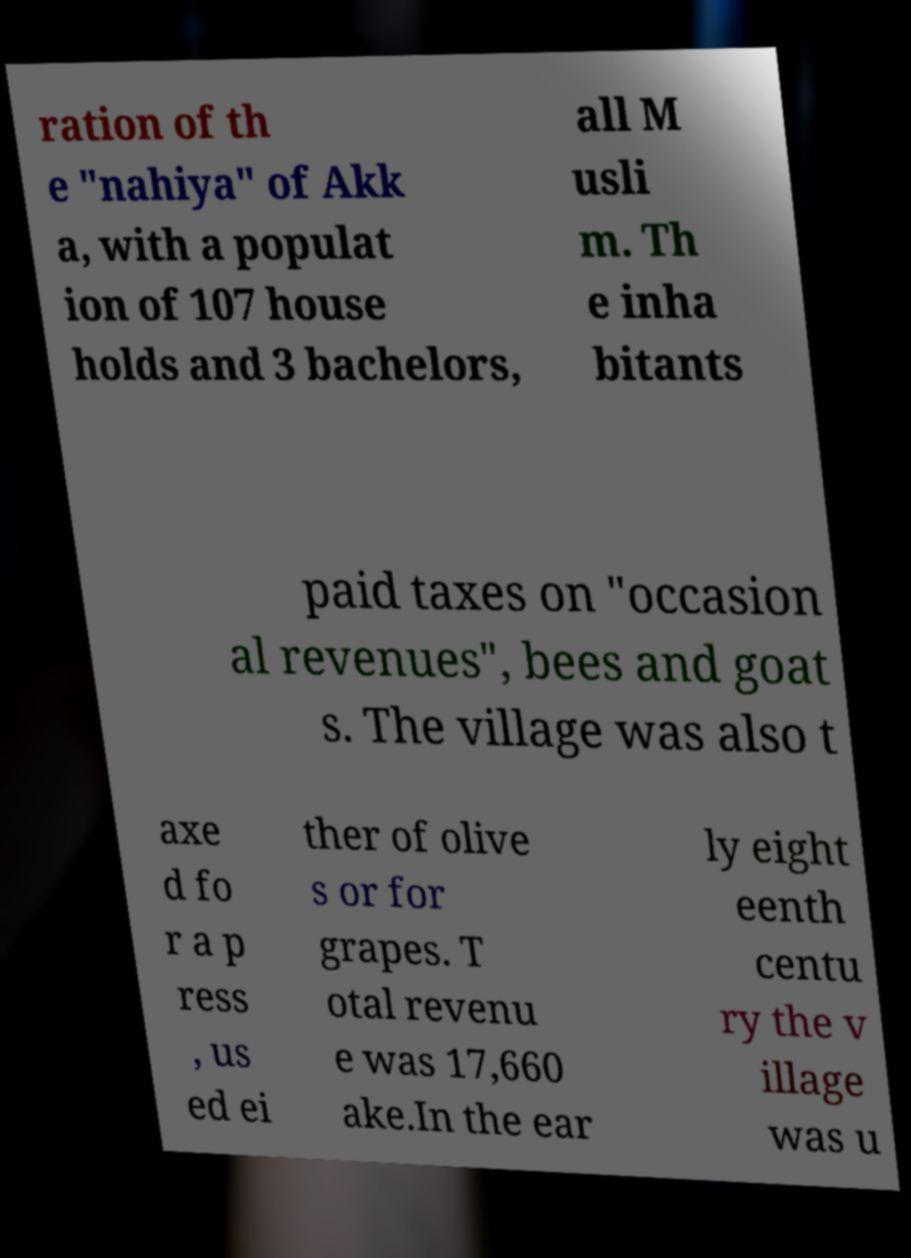Please identify and transcribe the text found in this image. ration of th e "nahiya" of Akk a, with a populat ion of 107 house holds and 3 bachelors, all M usli m. Th e inha bitants paid taxes on "occasion al revenues", bees and goat s. The village was also t axe d fo r a p ress , us ed ei ther of olive s or for grapes. T otal revenu e was 17,660 ake.In the ear ly eight eenth centu ry the v illage was u 